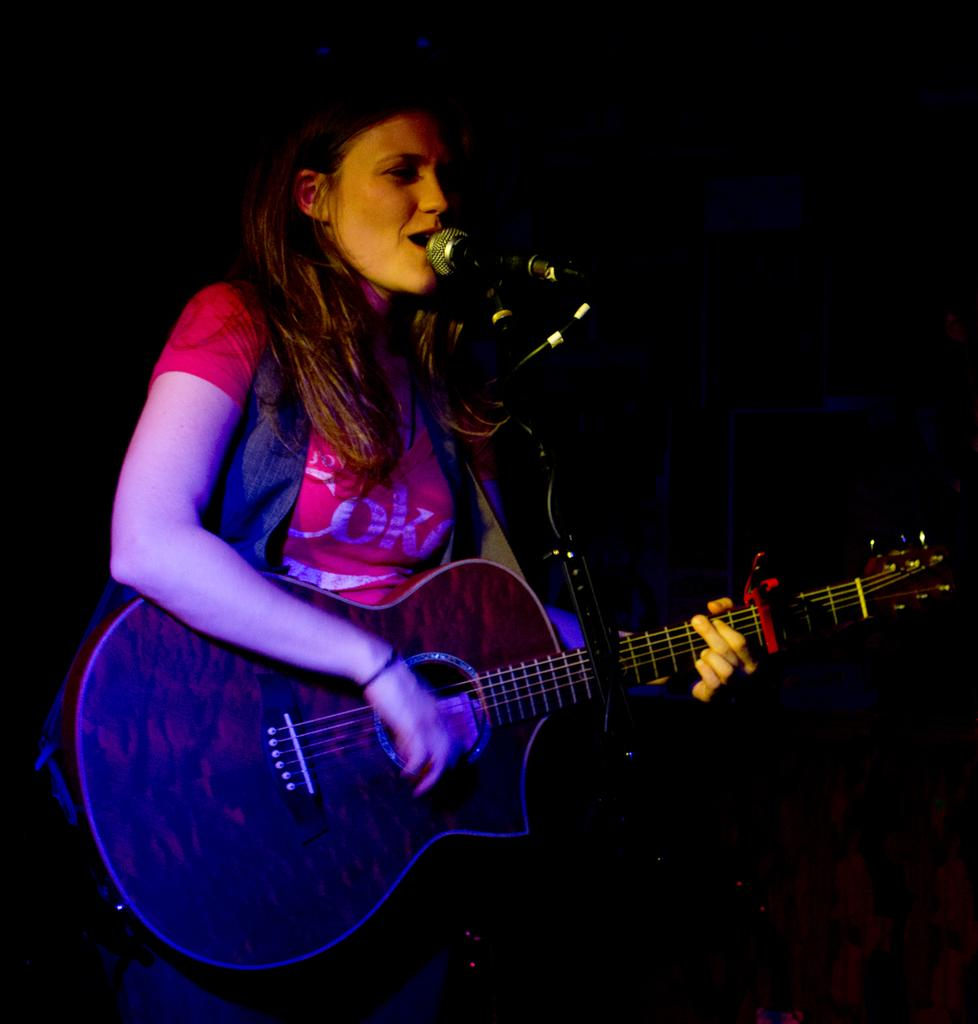Who is the main subject in the image? There is a woman in the image. What is the woman doing in the image? The woman is playing a guitar and singing on a microphone. Where is the sink located in the image? There is no sink present in the image. What type of church can be seen in the background of the image? There is no church visible in the image; it features a woman playing a guitar and singing on a microphone. 